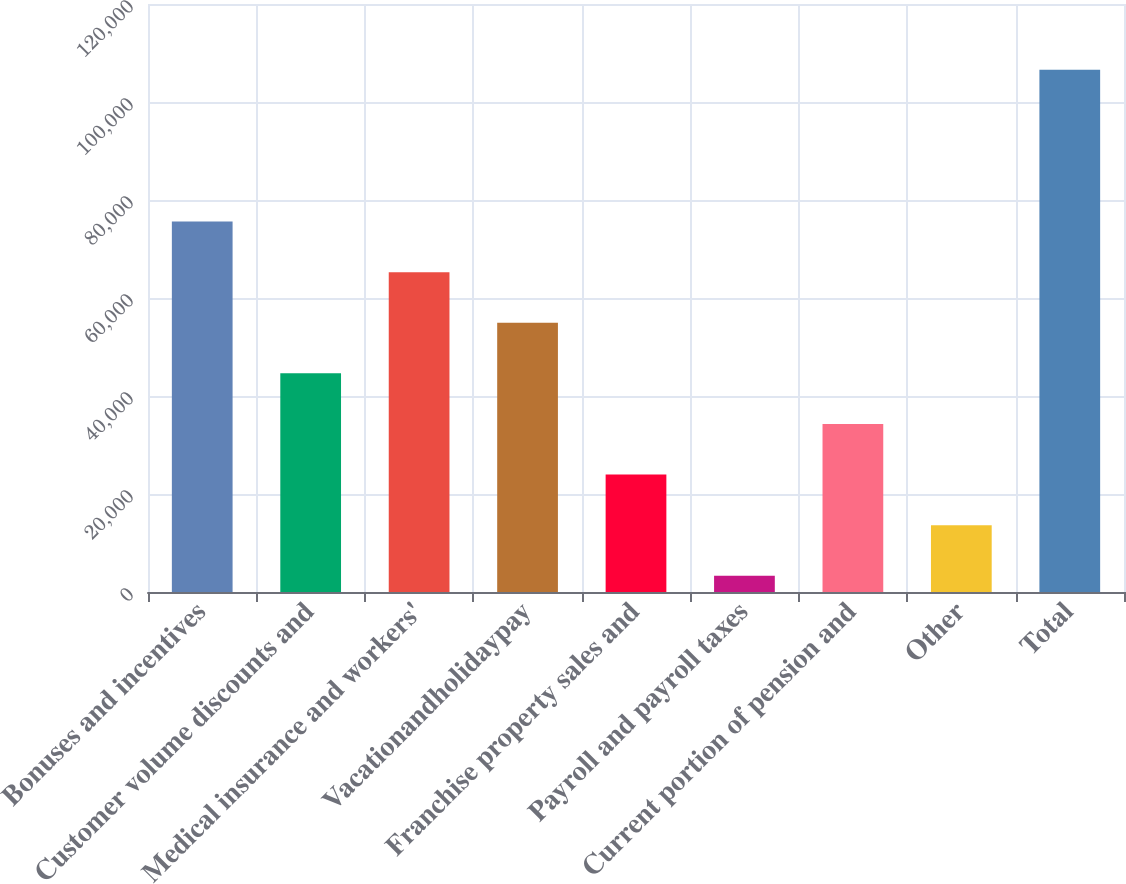Convert chart to OTSL. <chart><loc_0><loc_0><loc_500><loc_500><bar_chart><fcel>Bonuses and incentives<fcel>Customer volume discounts and<fcel>Medical insurance and workers'<fcel>Vacationandholidaypay<fcel>Franchise property sales and<fcel>Payroll and payroll taxes<fcel>Current portion of pension and<fcel>Other<fcel>Total<nl><fcel>75604.3<fcel>44620.6<fcel>65276.4<fcel>54948.5<fcel>23964.8<fcel>3309<fcel>34292.7<fcel>13636.9<fcel>106588<nl></chart> 